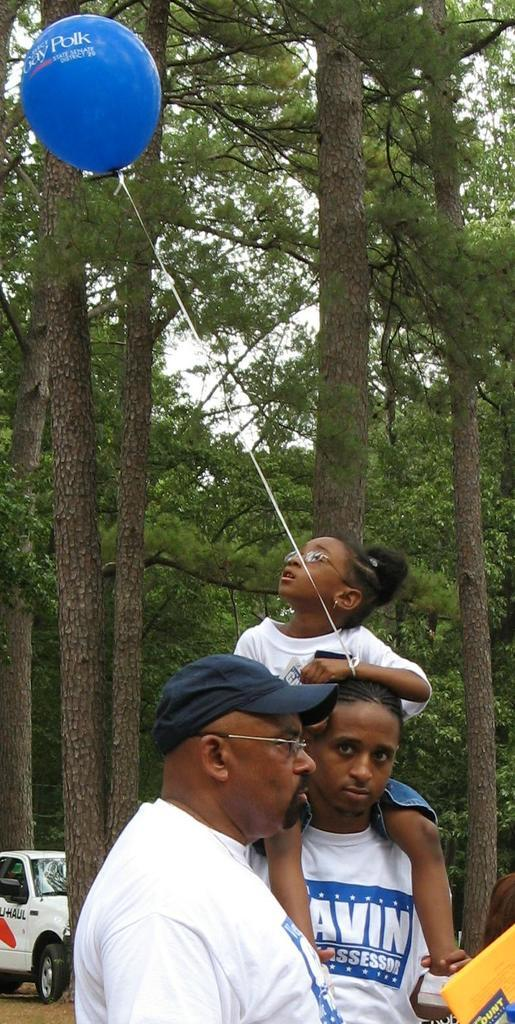How many people are in the image? There are two men and a girl in the image. What is the girl holding in the image? A balloon is tied to the girl's hand. What can be seen in the background of the image? There are trees and a car visible in the background. What type of chin is visible on the girl in the image? There is no chin visible on the girl in the image, as the image does not show the girl's face. 